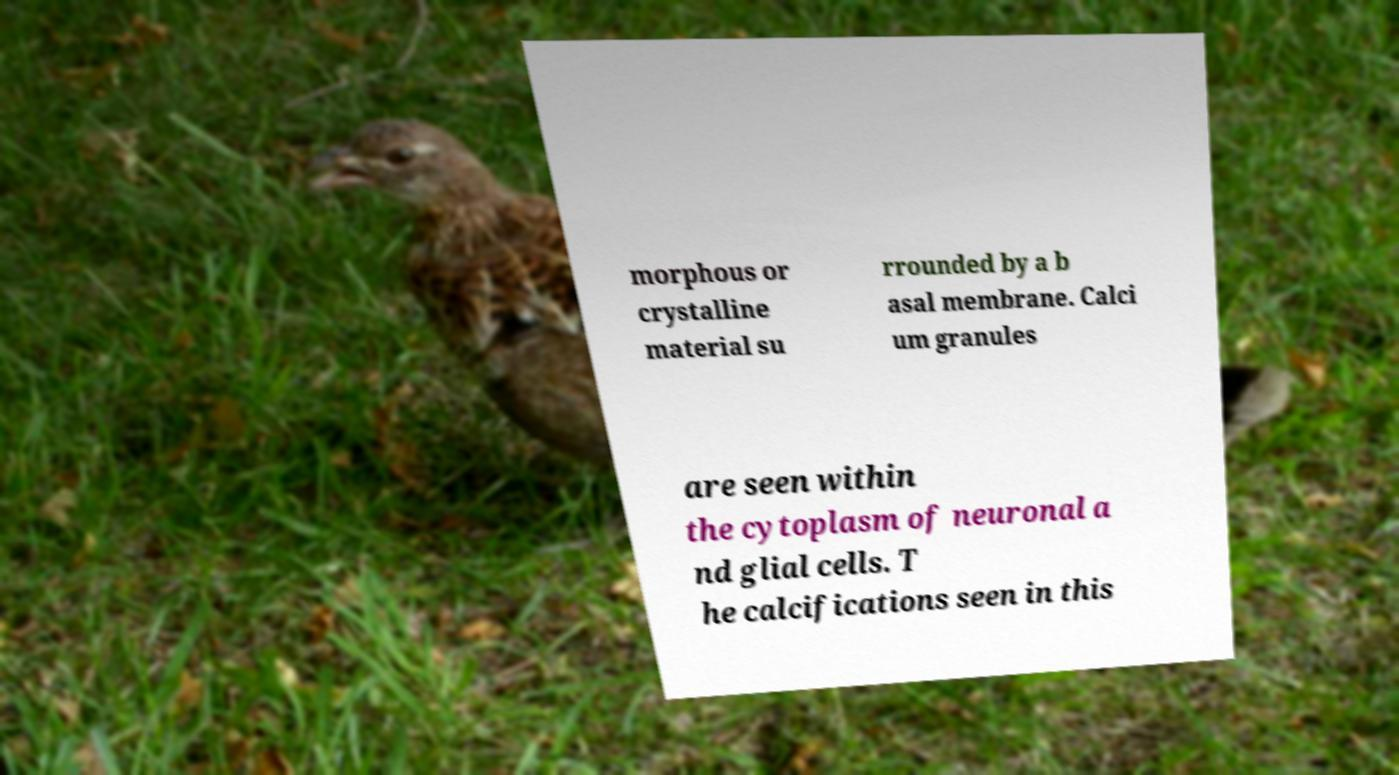Please read and relay the text visible in this image. What does it say? morphous or crystalline material su rrounded by a b asal membrane. Calci um granules are seen within the cytoplasm of neuronal a nd glial cells. T he calcifications seen in this 